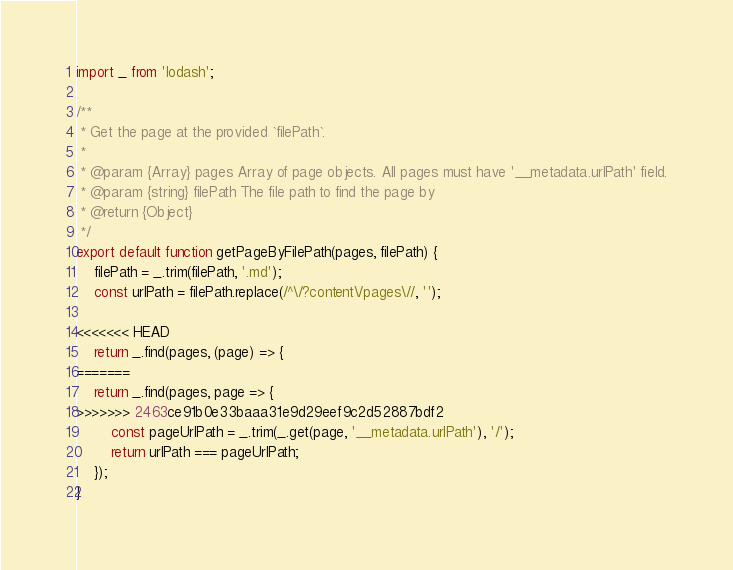<code> <loc_0><loc_0><loc_500><loc_500><_JavaScript_>import _ from 'lodash';

/**
 * Get the page at the provided `filePath`.
 *
 * @param {Array} pages Array of page objects. All pages must have '__metadata.urlPath' field.
 * @param {string} filePath The file path to find the page by
 * @return {Object}
 */
export default function getPageByFilePath(pages, filePath) {
    filePath = _.trim(filePath, '.md');
    const urlPath = filePath.replace(/^\/?content\/pages\//, '');

<<<<<<< HEAD
    return _.find(pages, (page) => {
=======
    return _.find(pages, page => {
>>>>>>> 2463ce91b0e33baaa31e9d29eef9c2d52887bdf2
        const pageUrlPath = _.trim(_.get(page, '__metadata.urlPath'), '/');
        return urlPath === pageUrlPath;
    });
}
</code> 